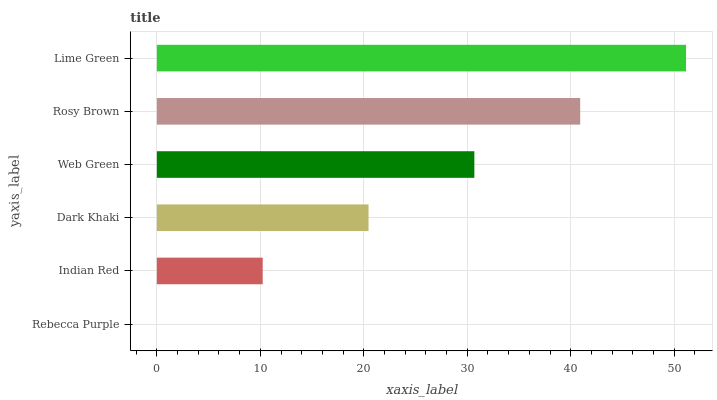Is Rebecca Purple the minimum?
Answer yes or no. Yes. Is Lime Green the maximum?
Answer yes or no. Yes. Is Indian Red the minimum?
Answer yes or no. No. Is Indian Red the maximum?
Answer yes or no. No. Is Indian Red greater than Rebecca Purple?
Answer yes or no. Yes. Is Rebecca Purple less than Indian Red?
Answer yes or no. Yes. Is Rebecca Purple greater than Indian Red?
Answer yes or no. No. Is Indian Red less than Rebecca Purple?
Answer yes or no. No. Is Web Green the high median?
Answer yes or no. Yes. Is Dark Khaki the low median?
Answer yes or no. Yes. Is Dark Khaki the high median?
Answer yes or no. No. Is Lime Green the low median?
Answer yes or no. No. 